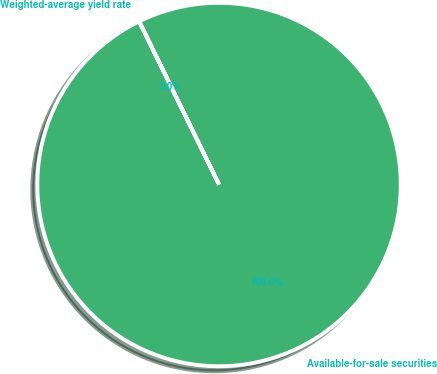Convert chart to OTSL. <chart><loc_0><loc_0><loc_500><loc_500><pie_chart><fcel>Available-for-sale securities<fcel>Weighted-average yield rate<nl><fcel>100.0%<fcel>0.0%<nl></chart> 